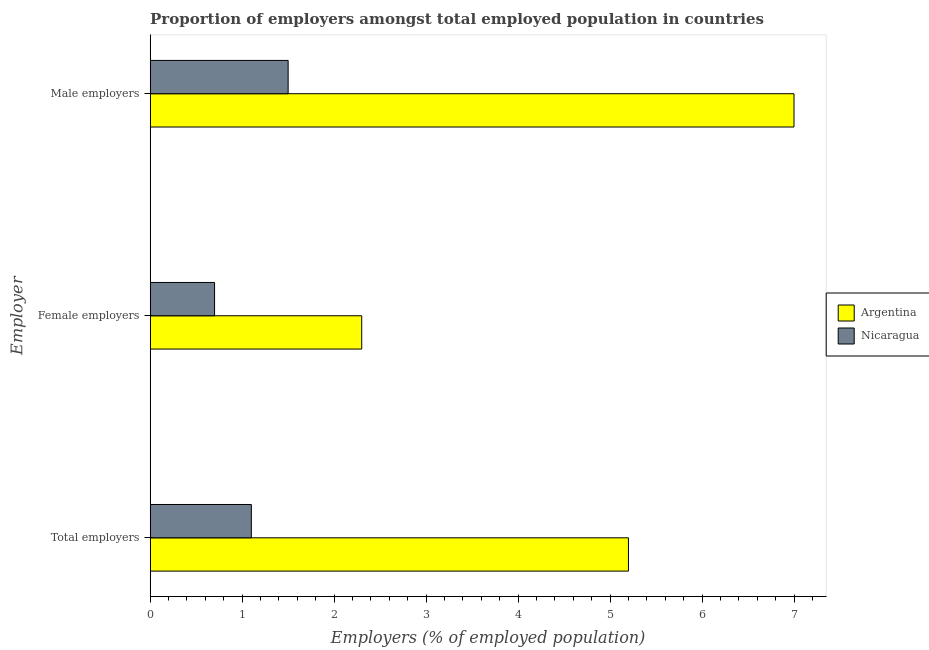Are the number of bars per tick equal to the number of legend labels?
Offer a very short reply. Yes. Are the number of bars on each tick of the Y-axis equal?
Offer a very short reply. Yes. How many bars are there on the 2nd tick from the top?
Offer a very short reply. 2. What is the label of the 3rd group of bars from the top?
Your answer should be compact. Total employers. What is the percentage of female employers in Nicaragua?
Your answer should be very brief. 0.7. Across all countries, what is the maximum percentage of total employers?
Keep it short and to the point. 5.2. Across all countries, what is the minimum percentage of male employers?
Your answer should be compact. 1.5. In which country was the percentage of female employers minimum?
Give a very brief answer. Nicaragua. What is the total percentage of female employers in the graph?
Make the answer very short. 3. What is the difference between the percentage of total employers in Argentina and that in Nicaragua?
Your answer should be compact. 4.1. What is the difference between the percentage of female employers in Nicaragua and the percentage of total employers in Argentina?
Give a very brief answer. -4.5. What is the average percentage of female employers per country?
Provide a short and direct response. 1.5. What is the difference between the percentage of female employers and percentage of male employers in Nicaragua?
Give a very brief answer. -0.8. What is the ratio of the percentage of total employers in Nicaragua to that in Argentina?
Offer a terse response. 0.21. Is the percentage of male employers in Nicaragua less than that in Argentina?
Your answer should be compact. Yes. Is the difference between the percentage of male employers in Nicaragua and Argentina greater than the difference between the percentage of total employers in Nicaragua and Argentina?
Your answer should be compact. No. What is the difference between the highest and the second highest percentage of female employers?
Give a very brief answer. 1.6. What is the difference between the highest and the lowest percentage of total employers?
Ensure brevity in your answer.  4.1. What does the 2nd bar from the top in Female employers represents?
Provide a succinct answer. Argentina. What does the 2nd bar from the bottom in Female employers represents?
Give a very brief answer. Nicaragua. How many bars are there?
Provide a short and direct response. 6. How many countries are there in the graph?
Ensure brevity in your answer.  2. How are the legend labels stacked?
Provide a short and direct response. Vertical. What is the title of the graph?
Offer a very short reply. Proportion of employers amongst total employed population in countries. Does "Brazil" appear as one of the legend labels in the graph?
Your answer should be compact. No. What is the label or title of the X-axis?
Your answer should be very brief. Employers (% of employed population). What is the label or title of the Y-axis?
Provide a succinct answer. Employer. What is the Employers (% of employed population) in Argentina in Total employers?
Give a very brief answer. 5.2. What is the Employers (% of employed population) in Nicaragua in Total employers?
Your answer should be very brief. 1.1. What is the Employers (% of employed population) of Argentina in Female employers?
Provide a succinct answer. 2.3. What is the Employers (% of employed population) in Nicaragua in Female employers?
Keep it short and to the point. 0.7. What is the Employers (% of employed population) of Argentina in Male employers?
Give a very brief answer. 7. Across all Employer, what is the maximum Employers (% of employed population) of Nicaragua?
Make the answer very short. 1.5. Across all Employer, what is the minimum Employers (% of employed population) in Argentina?
Give a very brief answer. 2.3. Across all Employer, what is the minimum Employers (% of employed population) in Nicaragua?
Provide a succinct answer. 0.7. What is the total Employers (% of employed population) of Nicaragua in the graph?
Provide a succinct answer. 3.3. What is the difference between the Employers (% of employed population) of Argentina in Total employers and that in Female employers?
Ensure brevity in your answer.  2.9. What is the difference between the Employers (% of employed population) in Argentina in Total employers and that in Male employers?
Your answer should be compact. -1.8. What is the difference between the Employers (% of employed population) of Argentina in Total employers and the Employers (% of employed population) of Nicaragua in Male employers?
Give a very brief answer. 3.7. What is the average Employers (% of employed population) of Argentina per Employer?
Your answer should be very brief. 4.83. What is the average Employers (% of employed population) in Nicaragua per Employer?
Provide a succinct answer. 1.1. What is the ratio of the Employers (% of employed population) in Argentina in Total employers to that in Female employers?
Offer a terse response. 2.26. What is the ratio of the Employers (% of employed population) in Nicaragua in Total employers to that in Female employers?
Your response must be concise. 1.57. What is the ratio of the Employers (% of employed population) of Argentina in Total employers to that in Male employers?
Ensure brevity in your answer.  0.74. What is the ratio of the Employers (% of employed population) of Nicaragua in Total employers to that in Male employers?
Make the answer very short. 0.73. What is the ratio of the Employers (% of employed population) of Argentina in Female employers to that in Male employers?
Offer a very short reply. 0.33. What is the ratio of the Employers (% of employed population) of Nicaragua in Female employers to that in Male employers?
Your response must be concise. 0.47. 